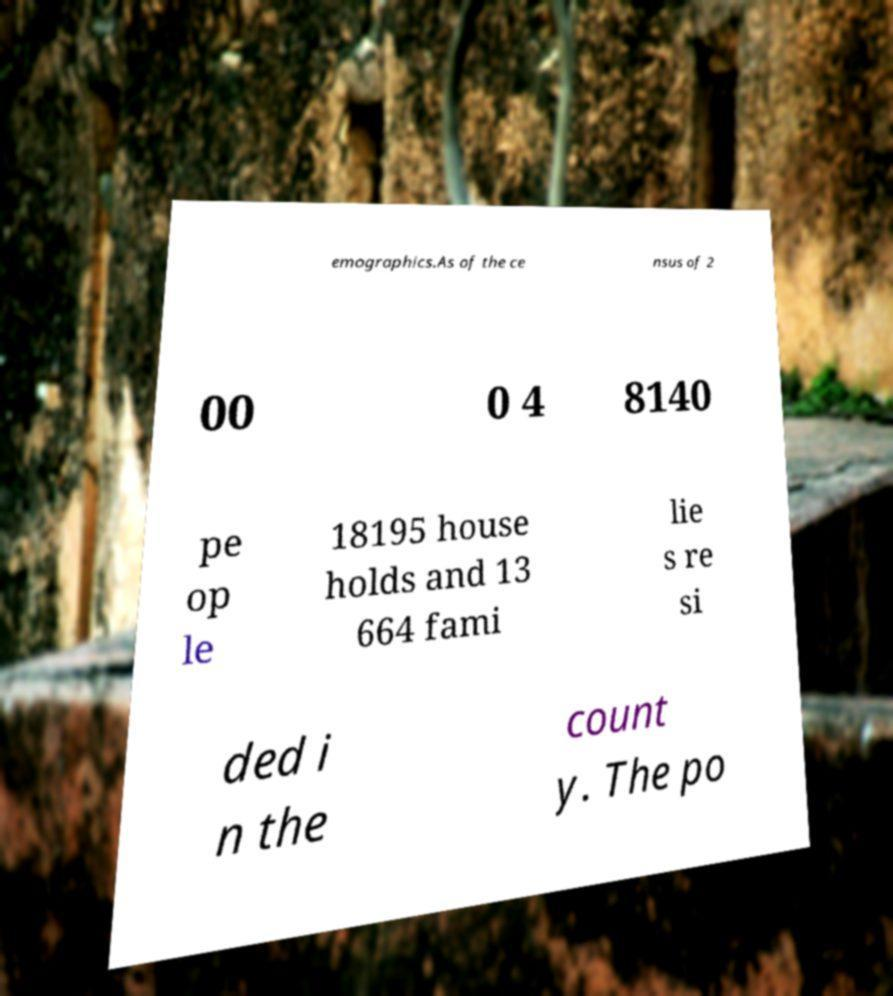For documentation purposes, I need the text within this image transcribed. Could you provide that? emographics.As of the ce nsus of 2 00 0 4 8140 pe op le 18195 house holds and 13 664 fami lie s re si ded i n the count y. The po 